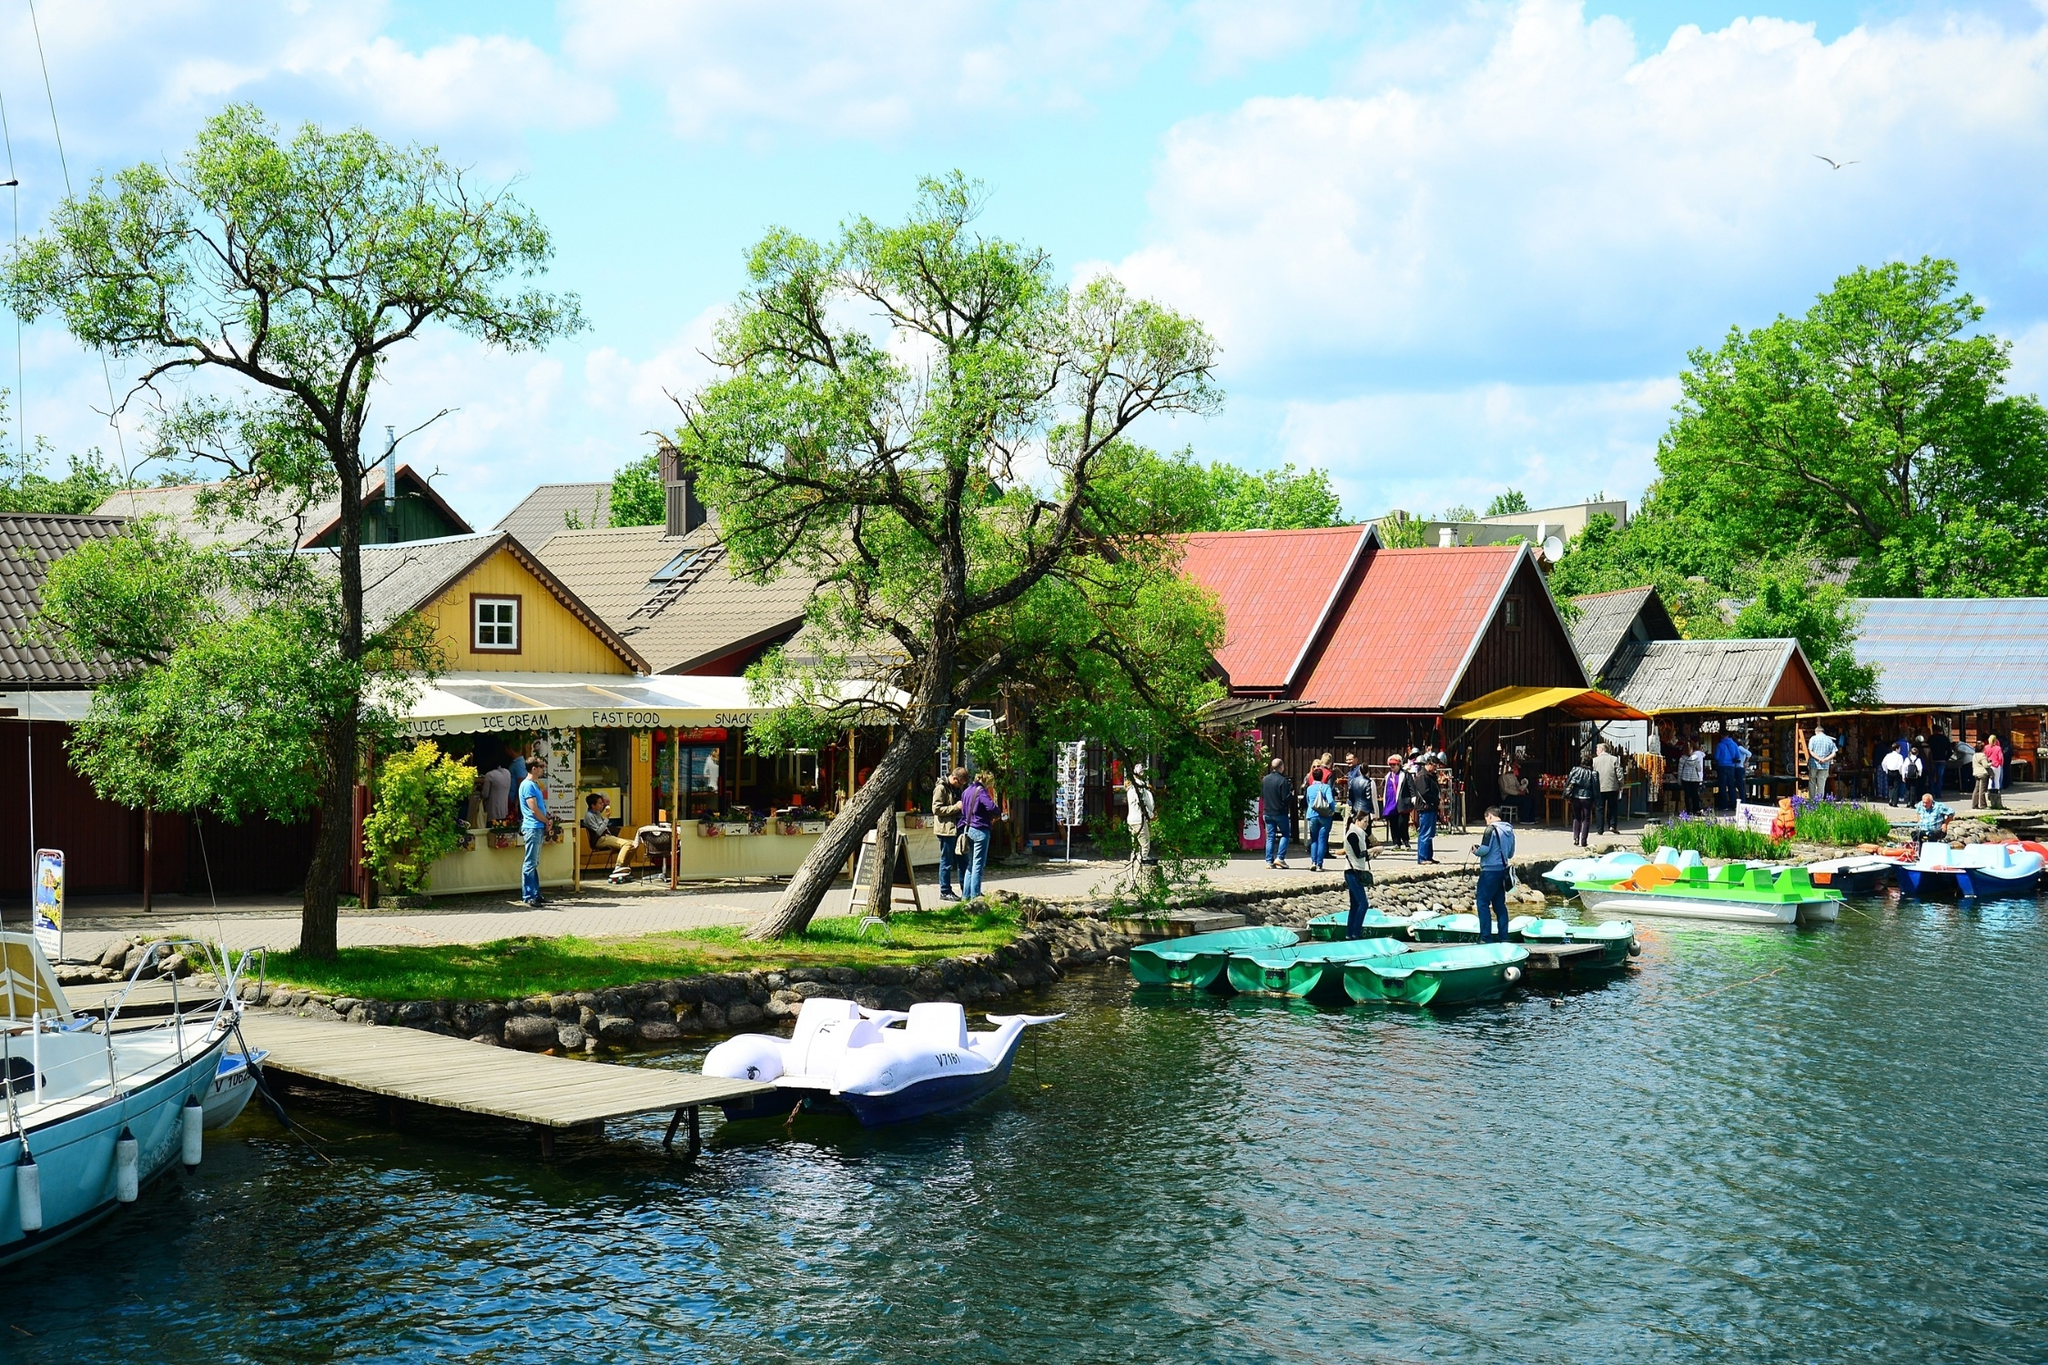If this village were part of a dream you had, describe how you would feel and what you would do. In a dream where I find myself in this serene village, I would feel an overwhelming sense of peace and joy. The vibrant greenery and the tranquil lake would invoke a feeling of being one with nature. I would start my day with a leisurely walk along the lakeshore, breathing in the fresh air and enjoying the gentle rustling of the leaves. I would spend time exploring the charming wooden houses, perhaps finding a cozy spot to sit and read a book while savoring an ice cream from the local kiosk. As the day progresses, I might take a paddle boat out on the lake, letting the calm waters soothe my soul. In the evening, I would watch the sunset, painting the sky in hues of orange and pink, reflecting beautifully on the lake's surface. The experience would leave me with a profound sense of contentment and a desire to return to this idyllic village in my dreams again and again. 